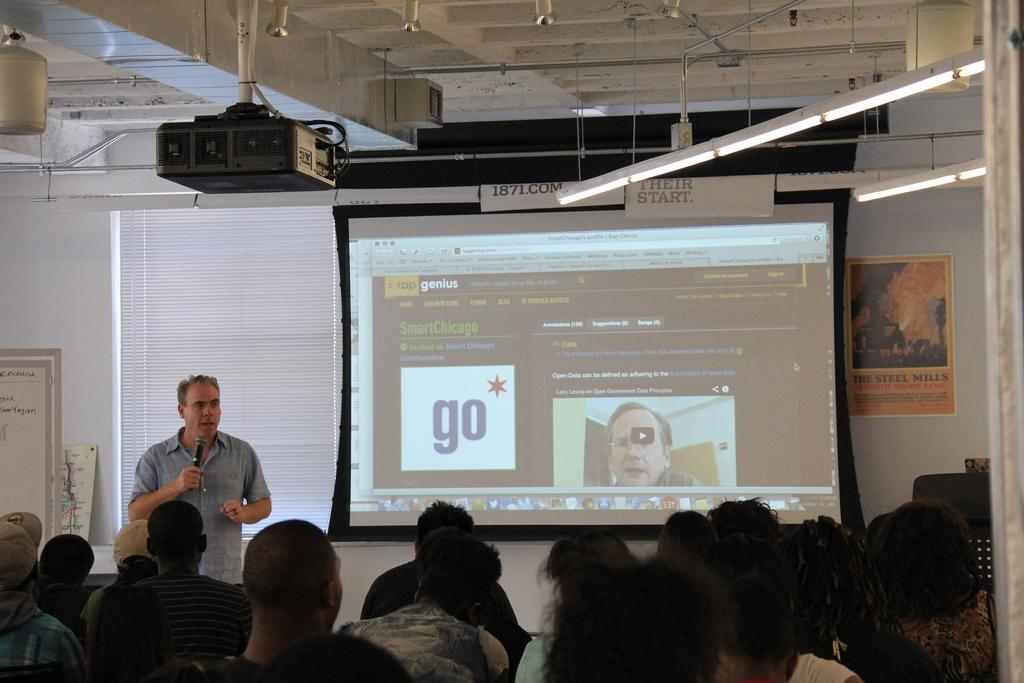What is the color of the wall in the image? The wall in the image is white. What can be seen on the wall? There is a screen on the wall in the image. What device is used to project images or videos onto the screen? There is a projector in the image. What type of lighting is present in the image? There are lights in the image. What is hanging on the wall? There is a banner in the image. What is the board used for in the image? There is a board in the image, which might be used for writing or displaying information. How are the people in the image positioned? There are people sitting on chairs in the image. Who is holding a microphone in the image? A man is holding a mic in the image. How many spiders are crawling on the banner in the image? There are no spiders present in the image. What type of bird is sitting on the projector in the image? There are no birds present in the image. 